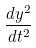Convert formula to latex. <formula><loc_0><loc_0><loc_500><loc_500>\frac { d y ^ { 2 } } { d t ^ { 2 } }</formula> 